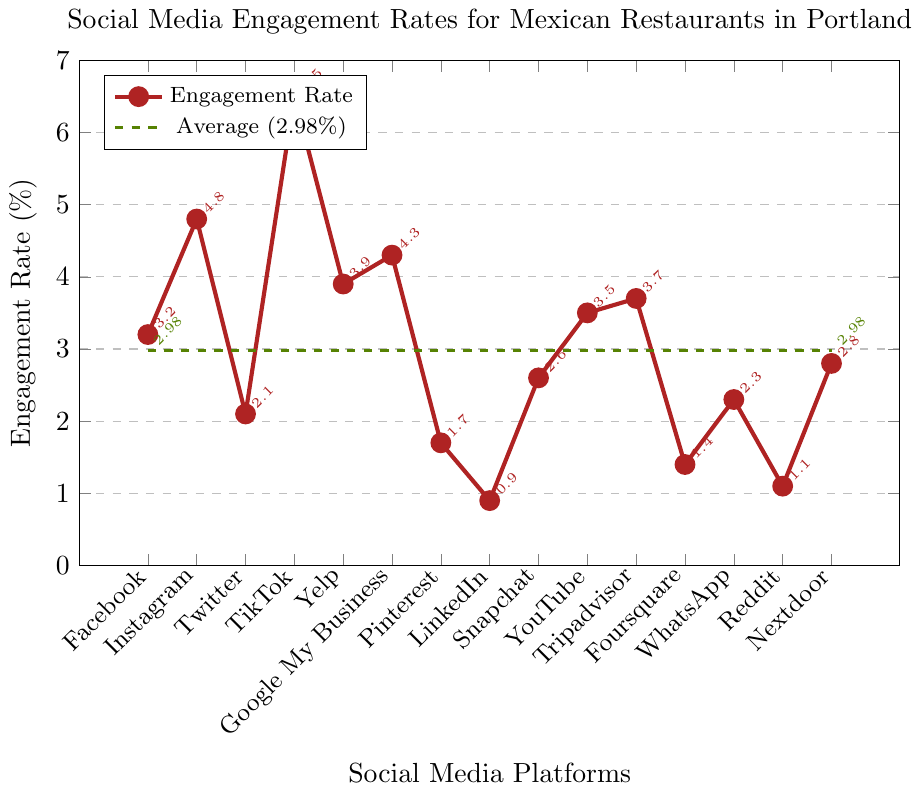Which platform has the highest engagement rate? Locate the highest point on the graph, which corresponds to TikTok with an engagement rate of 6.5%.
Answer: TikTok Which platform has the lowest engagement rate? Locate the lowest point on the graph, which corresponds to LinkedIn with an engagement rate of 0.9%.
Answer: LinkedIn How does the average engagement rate compare to the engagement rate of Yelp? The average engagement rate is shown as a dashed green line at 2.98%. Yelp's engagement rate is 3.9%, which is higher than the average.
Answer: Higher Is the engagement rate of Instagram greater than the engagement rate of YouTube? Locate the points for Instagram (4.8%) and YouTube (3.5%) on the graph. Instagram has a higher engagement rate.
Answer: Yes Which platform's engagement rate is closest to the average rate? The average engagement rate is 2.98%. The closest platform rate is Twitter, with an engagement rate of 2.1% (difference of 0.88).
Answer: Twitter Which two platforms have engagement rates slightly above the average? Observe the platforms and compare them to the average rate of 2.98%. Snapchat (2.6%) and Nextdoor (2.8%) are slightly below the average, while Yelp (3.9%) and Google My Business (4.3%) are just above it.
Answer: Yelp, Google My Business What is the difference between the highest and lowest engagement rates? The highest engagement rate is TikTok at 6.5%, and the lowest is LinkedIn at 0.9%. The difference is 6.5 - 0.9 = 5.6%.
Answer: 5.6% How many platforms have an engagement rate higher than the average? Identify all platforms with rates above the 2.98% average: Facebook, Instagram, TikTok, Yelp, Google My Business, YouTube, and Tripadvisor.
Answer: 7 platforms How does the engagement rate of Pinterest compare to that of WhatsApp? Locate the points for Pinterest (1.7%) and WhatsApp (2.3%). WhatsApp has a higher engagement rate.
Answer: Lower Which two platforms have engagement rates between 3% and 4%? Find the platforms within the range of 3-4%. They are Facebook (3.2%) and YouTube (3.5%).
Answer: Facebook, YouTube 